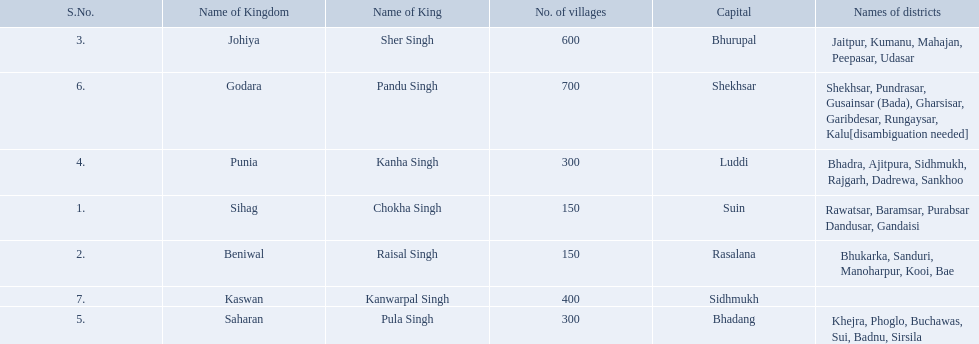What is the most amount of villages in a kingdom? 700. What is the second most amount of villages in a kingdom? 600. What kingdom has 600 villages? Johiya. 